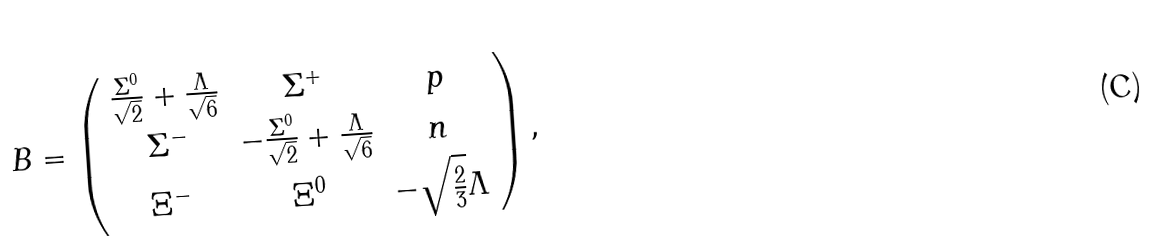<formula> <loc_0><loc_0><loc_500><loc_500>B = \left ( \begin{array} { c c c } \frac { \Sigma ^ { 0 } } { \sqrt { 2 } } + \frac { \Lambda } { \sqrt { 6 } } & \Sigma ^ { + } & p \\ \Sigma ^ { - } & - \frac { \Sigma ^ { 0 } } { \sqrt { 2 } } + \frac { \Lambda } { \sqrt { 6 } } & n \\ \Xi ^ { - } & \Xi ^ { 0 } & - \sqrt { \frac { 2 } { 3 } } \Lambda \end{array} \right ) ,</formula> 